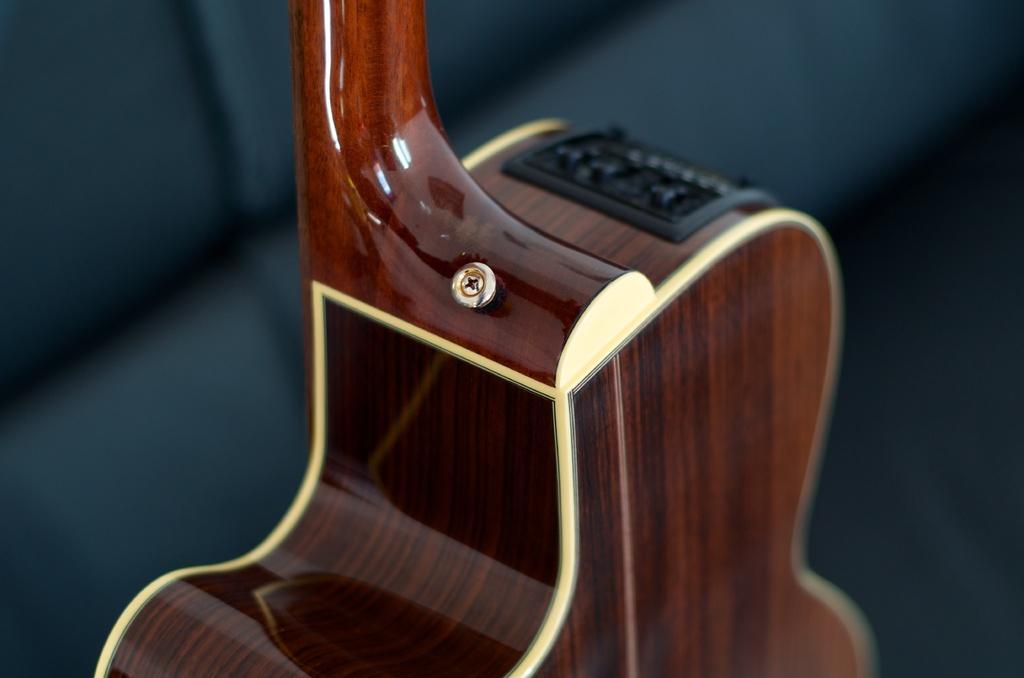Could you give a brief overview of what you see in this image? In this image I can see guitar of brown color made of wood. 